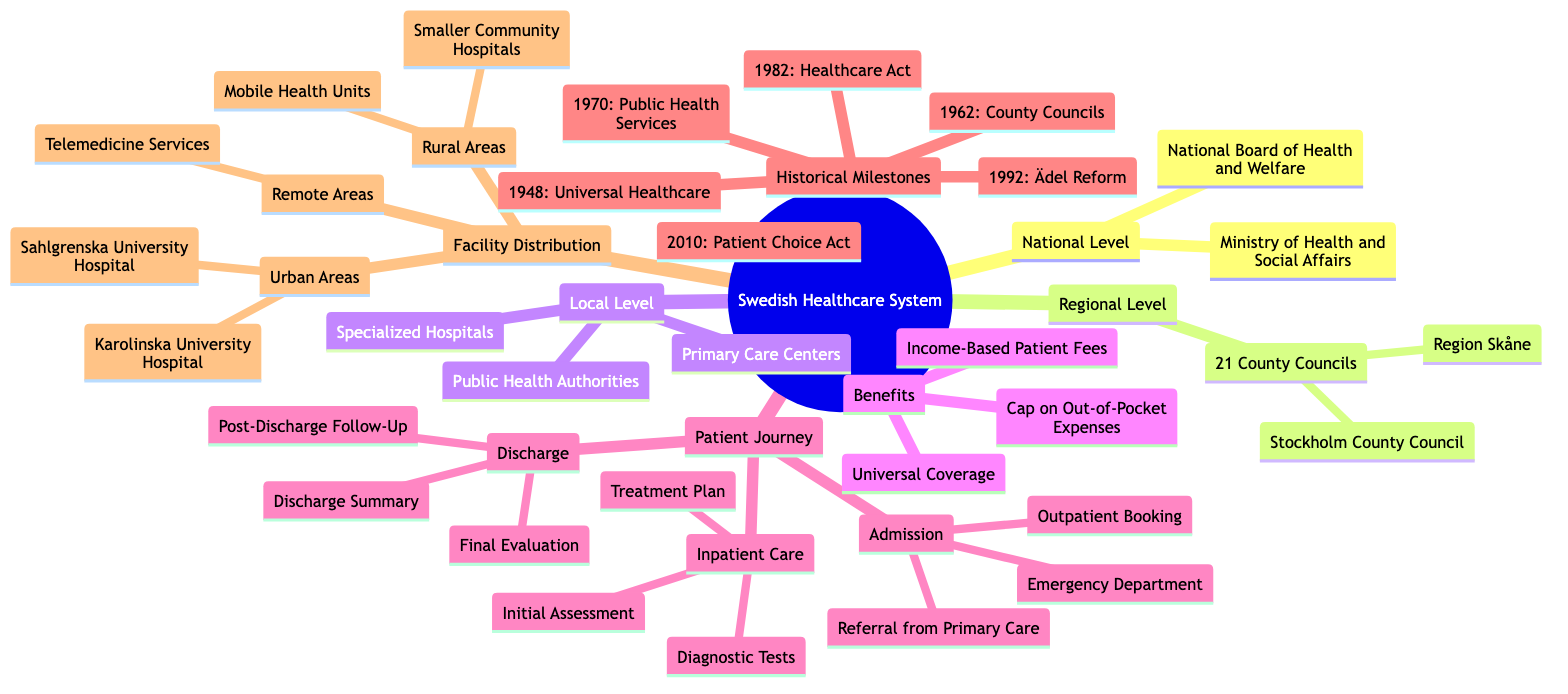What is the highest level of the Swedish healthcare system? The diagram outlines three levels of the Swedish healthcare system: National, Regional, and Local. The highest level, as indicated, is the National Level where the Ministry of Health and Social Affairs and the National Board of Health and Welfare are located.
Answer: National Level How many County Councils are there in Sweden? The diagram specifies that there are 21 County Councils at the Regional Level of the Swedish healthcare system. This is a direct count from the information presented in the diagram.
Answer: 21 What is one benefit of the Swedish healthcare system? One benefit highlighted in the Benefits section of the diagram is Universal Coverage. This is a significant feature that ensures all citizens have access to healthcare services.
Answer: Universal Coverage Which council includes the Karolinska University Hospital? The diagram indicates that Karolinska University Hospital is part of the Urban Areas distribution under the Local Level category. This information reflects the specific healthcare facility's classification by location.
Answer: Stockholm County Council What year was universal healthcare established in Sweden? The Historical Milestones section lists key events, with the year 1948 specified for the introduction of universal healthcare in Sweden. This is a crucial date for understanding the evolution of Sweden's healthcare policies.
Answer: 1948 How many stages are there in the patient journey outlined in the diagram? The Patient Journey section in the diagram contains three distinct stages: Admission, Inpatient Care, and Discharge. Counting these stages shows the complexity and steps involved in a patient's interaction with the healthcare system.
Answer: 3 What type of services are provided in remote areas according to the diagram? The diagram states that Telemedicine Services are utilized in remote areas to ensure healthcare access. This highlights the innovative approaches in Sweden to reach patients in less accessible locations.
Answer: Telemedicine Services Which reform was introduced in 2010? The Historical Milestones section of the diagram mentions the Patient Choice Act as the reform that took place in 2010, demonstrating a significant policy change aimed at enhancing patient autonomy in healthcare.
Answer: Patient Choice Act What follows the Initial Assessment in the inpatient care stage? The pathway outlined in the Patient Journey section shows that after the Initial Assessment, the next step involves Diagnostic Tests. This illustrates the sequential nature of the care process.
Answer: Diagnostic Tests 